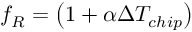Convert formula to latex. <formula><loc_0><loc_0><loc_500><loc_500>f _ { R } = \left ( 1 + \alpha \Delta T _ { c h i p } \right )</formula> 